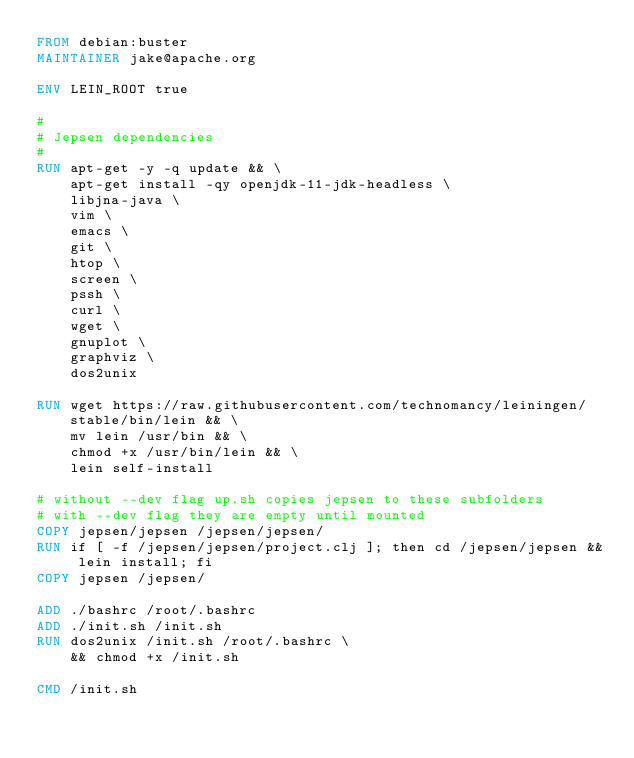Convert code to text. <code><loc_0><loc_0><loc_500><loc_500><_Dockerfile_>FROM debian:buster
MAINTAINER jake@apache.org

ENV LEIN_ROOT true

#
# Jepsen dependencies
#
RUN apt-get -y -q update && \
    apt-get install -qy openjdk-11-jdk-headless \
    libjna-java \
    vim \
    emacs \
    git \
    htop \
    screen \
    pssh \
    curl \
    wget \
    gnuplot \
    graphviz \
    dos2unix

RUN wget https://raw.githubusercontent.com/technomancy/leiningen/stable/bin/lein && \
    mv lein /usr/bin && \
    chmod +x /usr/bin/lein && \
    lein self-install

# without --dev flag up.sh copies jepsen to these subfolders
# with --dev flag they are empty until mounted
COPY jepsen/jepsen /jepsen/jepsen/
RUN if [ -f /jepsen/jepsen/project.clj ]; then cd /jepsen/jepsen && lein install; fi
COPY jepsen /jepsen/

ADD ./bashrc /root/.bashrc
ADD ./init.sh /init.sh
RUN dos2unix /init.sh /root/.bashrc \
    && chmod +x /init.sh

CMD /init.sh
</code> 